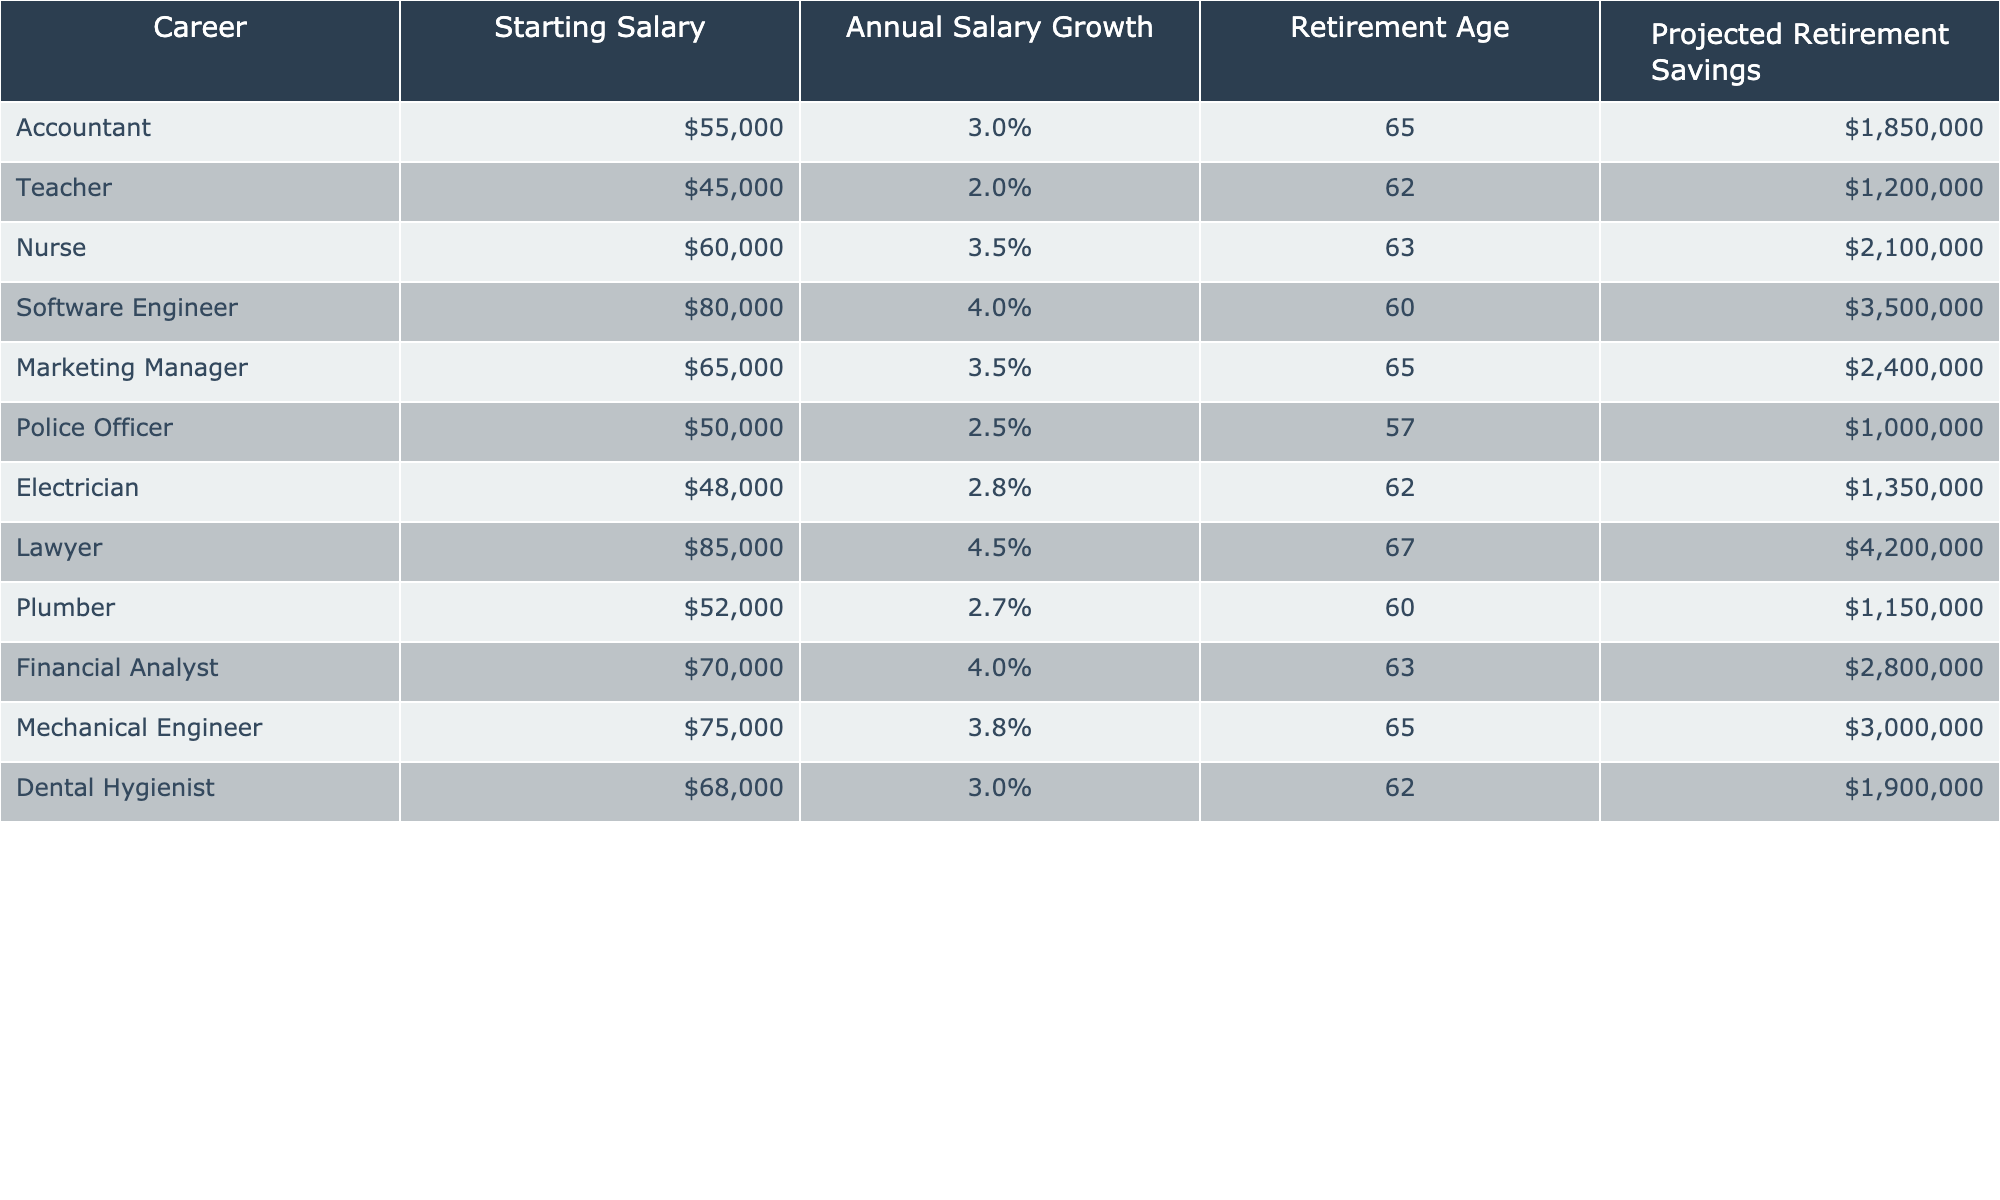What is the projected retirement savings for a Software Engineer? The table shows that the projected retirement savings for a Software Engineer is listed directly under the "Projected Retirement Savings" column. It states $3,500,000.
Answer: $3,500,000 Which career has the highest projected retirement savings? By examining the "Projected Retirement Savings" column, the Lawyer has the highest value at $4,200,000 compared to other careers listed.
Answer: Lawyer What is the average starting salary for the careers listed in the table? The starting salaries for the careers are: $55,000 (Accountant), $45,000 (Teacher), $60,000 (Nurse), $80,000 (Software Engineer), $65,000 (Marketing Manager), $50,000 (Police Officer), $48,000 (Electrician), $52,000 (Plumber), $70,000 (Financial Analyst), $75,000 (Mechanical Engineer), and $68,000 (Dental Hygienist). There are 11 salaries, and their sum is $55,000 + $45,000 + $60,000 + $80,000 + $65,000 + $50,000 + $48,000 + $52,000 + $70,000 + $75,000 + $68,000 = $1,078,000. Then dividing this by 11 gives an average of $98,000.
Answer: $98,000 Is the annual salary growth for Nurses higher than that for Teachers? The "Annual Salary Growth" for Nurses is noted as 3.5%, while for Teachers it is 2%. Since 3.5% is greater than 2%, the answer is yes, the growth for Nurses is higher.
Answer: Yes What is the difference in projected retirement savings between the highest and lowest earning careers? The highest projected retirement savings is for the Lawyer at $4,200,000, and the lowest is for the Police Officer at $1,000,000. The difference can be calculated as $4,200,000 - $1,000,000 = $3,200,000.
Answer: $3,200,000 Which professions have a retirement age of 65? Referring to the retirement age column, the careers that retire at age 65 are Accountant, Marketing Manager, Mechanical Engineer, and Nurse. Counting these professions gives four in total.
Answer: 4 If someone were to choose between a Dental Hygienist and a Plumber based solely on projected retirement savings, which should they choose? The projected retirement savings for a Dental Hygienist is $1,900,000, while for a Plumber it is $1,150,000. Since $1,900,000 is greater, it would be wise to choose Dental Hygienist for higher savings.
Answer: Dental Hygienist What impact does the annual salary growth have on the projected retirement savings over time in this table? Although this requires some inference, typically a higher annual salary growth means greater accumulated savings at retirement age due to increased salary over the years. Therefore, careers with higher annual salary growth, such as Software Engineers and Lawyers, tend to have higher projected retirement savings.
Answer: Higher growth leads to higher savings 